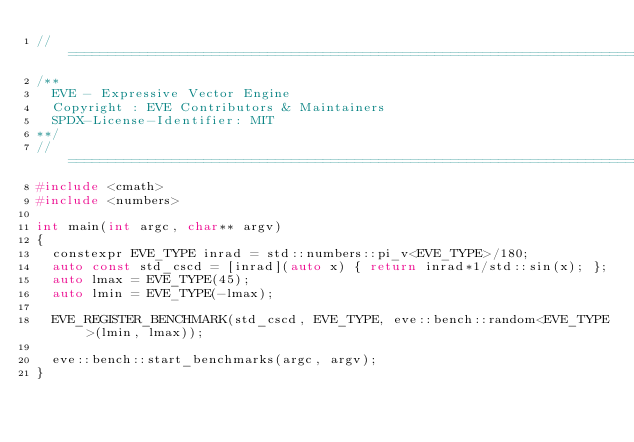Convert code to text. <code><loc_0><loc_0><loc_500><loc_500><_C++_>//==================================================================================================
/**
  EVE - Expressive Vector Engine
  Copyright : EVE Contributors & Maintainers
  SPDX-License-Identifier: MIT
**/
//==================================================================================================
#include <cmath>
#include <numbers>

int main(int argc, char** argv)
{
  constexpr EVE_TYPE inrad = std::numbers::pi_v<EVE_TYPE>/180;
  auto const std_cscd = [inrad](auto x) { return inrad*1/std::sin(x); };
  auto lmax = EVE_TYPE(45);
  auto lmin = EVE_TYPE(-lmax);

  EVE_REGISTER_BENCHMARK(std_cscd, EVE_TYPE, eve::bench::random<EVE_TYPE>(lmin, lmax));

  eve::bench::start_benchmarks(argc, argv);
}
</code> 